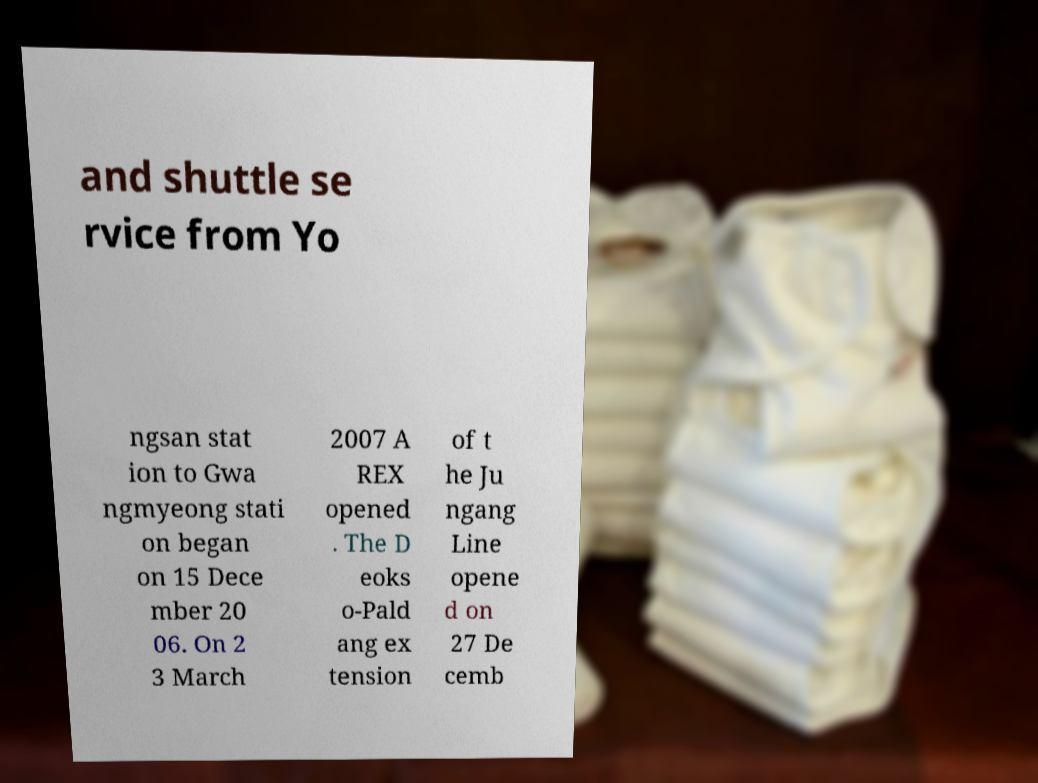Please read and relay the text visible in this image. What does it say? and shuttle se rvice from Yo ngsan stat ion to Gwa ngmyeong stati on began on 15 Dece mber 20 06. On 2 3 March 2007 A REX opened . The D eoks o-Pald ang ex tension of t he Ju ngang Line opene d on 27 De cemb 